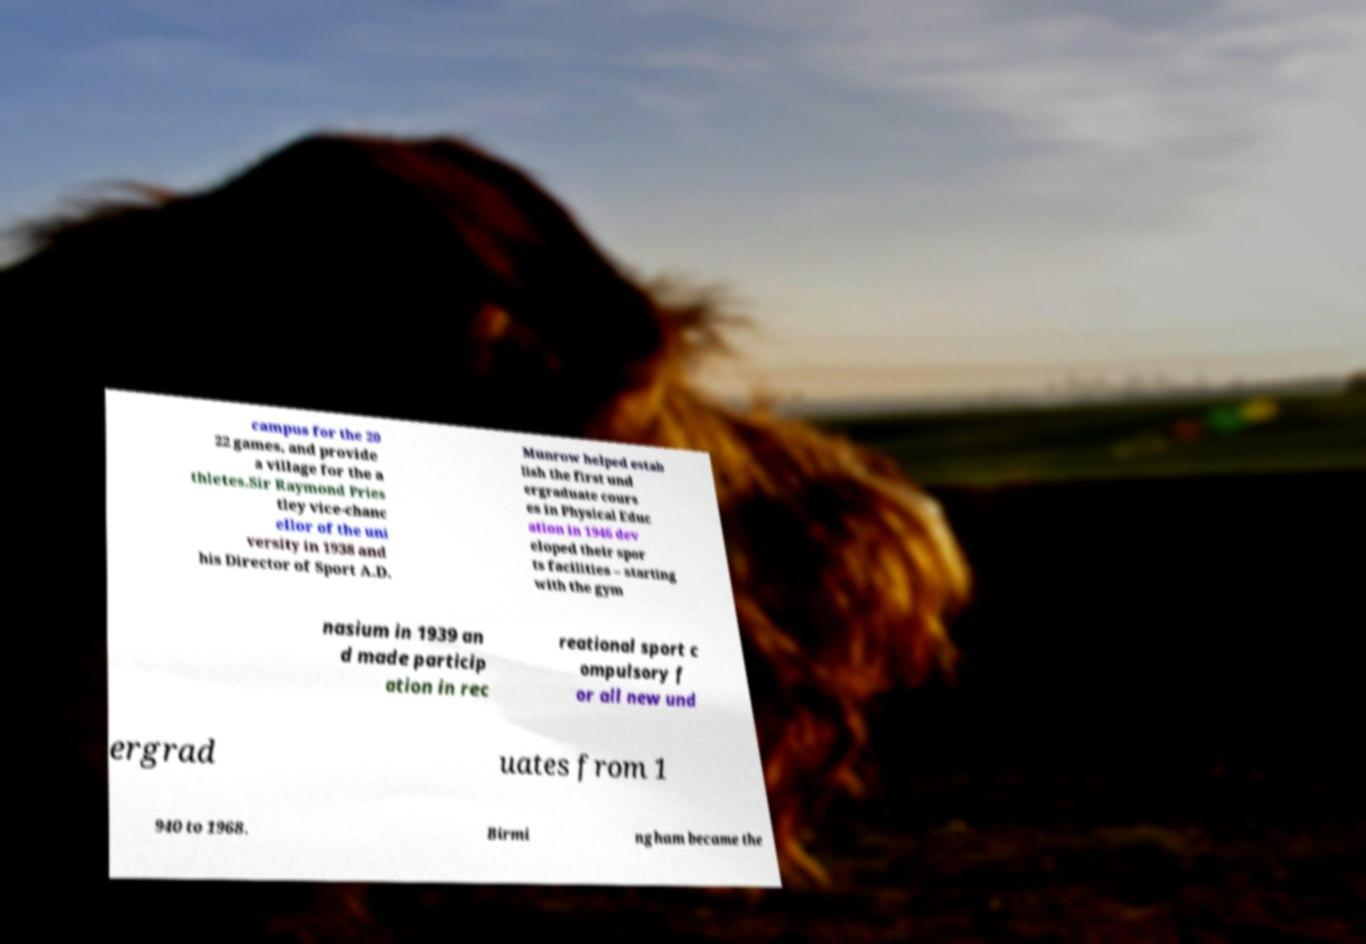Please read and relay the text visible in this image. What does it say? campus for the 20 22 games, and provide a village for the a thletes.Sir Raymond Pries tley vice-chanc ellor of the uni versity in 1938 and his Director of Sport A.D. Munrow helped estab lish the first und ergraduate cours es in Physical Educ ation in 1946 dev eloped their spor ts facilities – starting with the gym nasium in 1939 an d made particip ation in rec reational sport c ompulsory f or all new und ergrad uates from 1 940 to 1968. Birmi ngham became the 